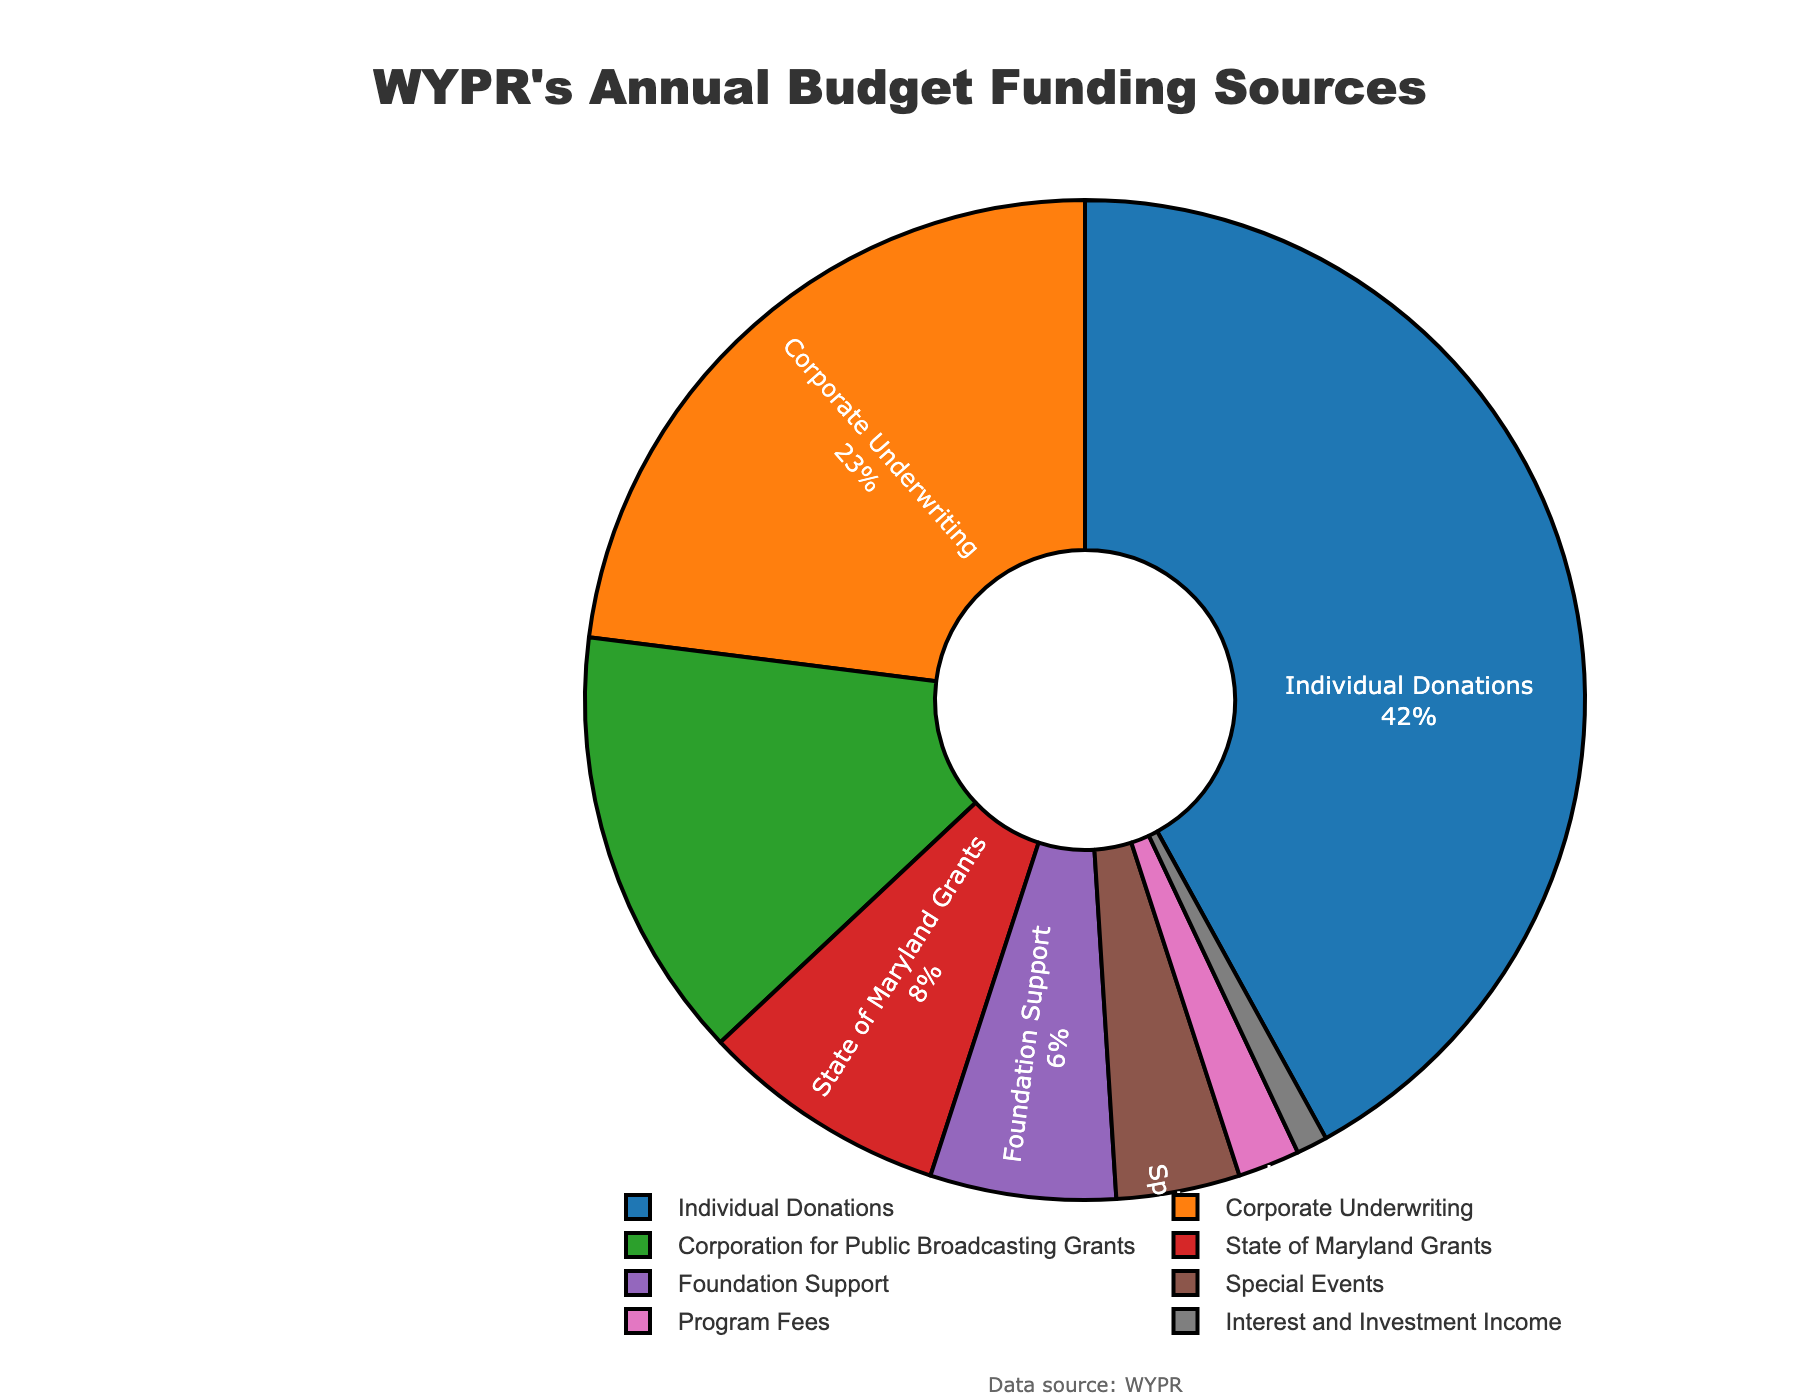What percentage of WYPR's funding comes from individual donations? To find the percentage of WYPR's funding from individual donations, look for the "Individual Donations" segment in the pie chart and read the corresponding percentage.
Answer: 42% Which funding source contributes the least to WYPR's annual budget? Examine the segments of the pie chart to find the one with the smallest percentage. The "Interest and Investment Income" segment is the smallest.
Answer: Interest and Investment Income How much more funding does corporate underwriting contribute compared to state grants? Identify the percentages for "Corporate Underwriting" (23%) and "State of Maryland Grants" (8%). Subtract the percentage for state grants from that for corporate underwriting: 23% - 8% = 15%.
Answer: 15% Which funding source is the third largest contributor to WYPR's annual budget? Look for the third-largest segment in the pie chart. The largest (42%) is Individual Donations, the second largest (23%) is Corporate Underwriting, and the third largest (14%) is Corporation for Public Broadcasting Grants.
Answer: Corporation for Public Broadcasting Grants What is the combined percentage of funding from special events and program fees? Add the percentages of "Special Events" (4%) and "Program Fees" (2%): 4% + 2% = 6%.
Answer: 6% Are state grants a larger or smaller contribution than foundation support? Compare the percentages of "State of Maryland Grants" (8%) and "Foundation Support" (6%). State grants contribute more.
Answer: Larger What color represents the 'Corporate Underwriting' segment in the pie chart? Identify the segment labeled "Corporate Underwriting" and observe its color. It is represented in orange.
Answer: Orange If Foundation Support and Program Fees were combined into a single category, what would be its rank in terms of contribution size? Calculate the combined percentage: 6% (Foundation Support) + 2% (Program Fees) = 8%. Then compare 8% with the other segments: Individual Donations (42%), Corporate Underwriting (23%), Corporation for Public Broadcasting Grants (14%), and State of Maryland Grants (8%). It would tie for fourth place along with State of Maryland Grants.
Answer: Fourth place (tie) What are the main colors used in the chart to differentiate the segments? Observe the colors used for the various segments in the pie chart. The main colors are blue, orange, green, red, purple, brown, pink, and gray.
Answer: Blue, orange, green, red, purple, brown, pink, gray Which two segments combined make up the largest portion of WYPR's budget, and what is their total percentage? Identify the largest and second-largest segments: Individual Donations (42%) and Corporate Underwriting (23%). Add these percentages: 42% + 23% = 65%.
Answer: Individual Donations and Corporate Underwriting, 65% 